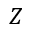Convert formula to latex. <formula><loc_0><loc_0><loc_500><loc_500>Z</formula> 